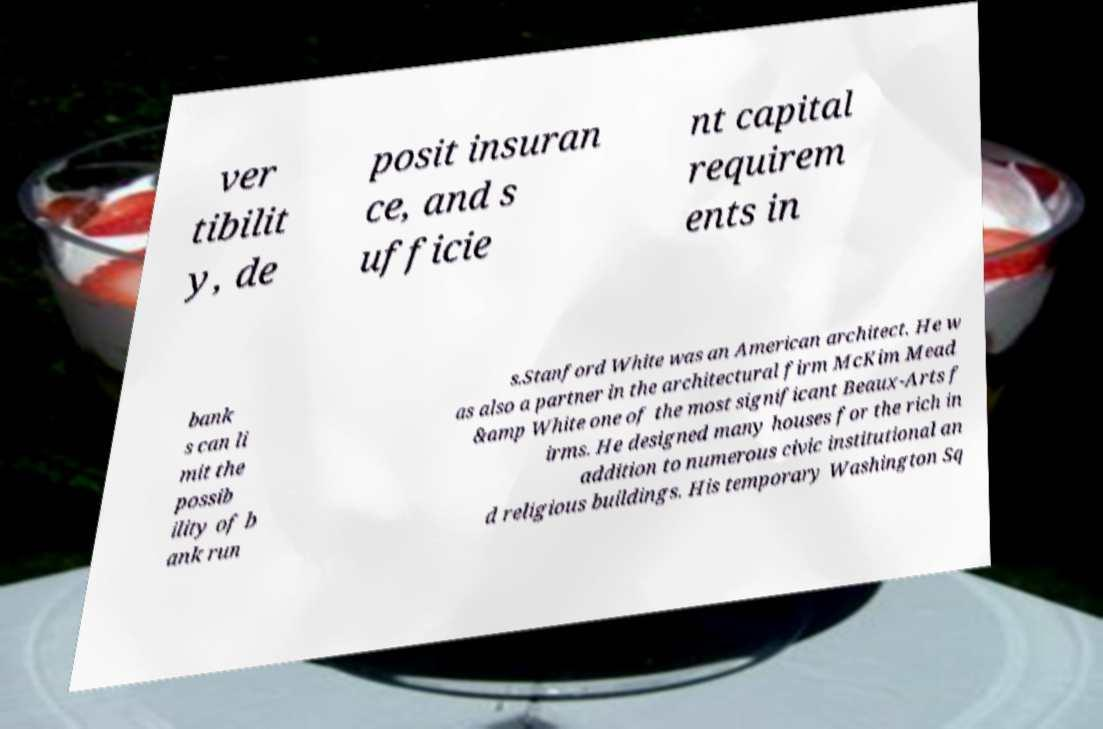There's text embedded in this image that I need extracted. Can you transcribe it verbatim? ver tibilit y, de posit insuran ce, and s ufficie nt capital requirem ents in bank s can li mit the possib ility of b ank run s.Stanford White was an American architect. He w as also a partner in the architectural firm McKim Mead &amp White one of the most significant Beaux-Arts f irms. He designed many houses for the rich in addition to numerous civic institutional an d religious buildings. His temporary Washington Sq 